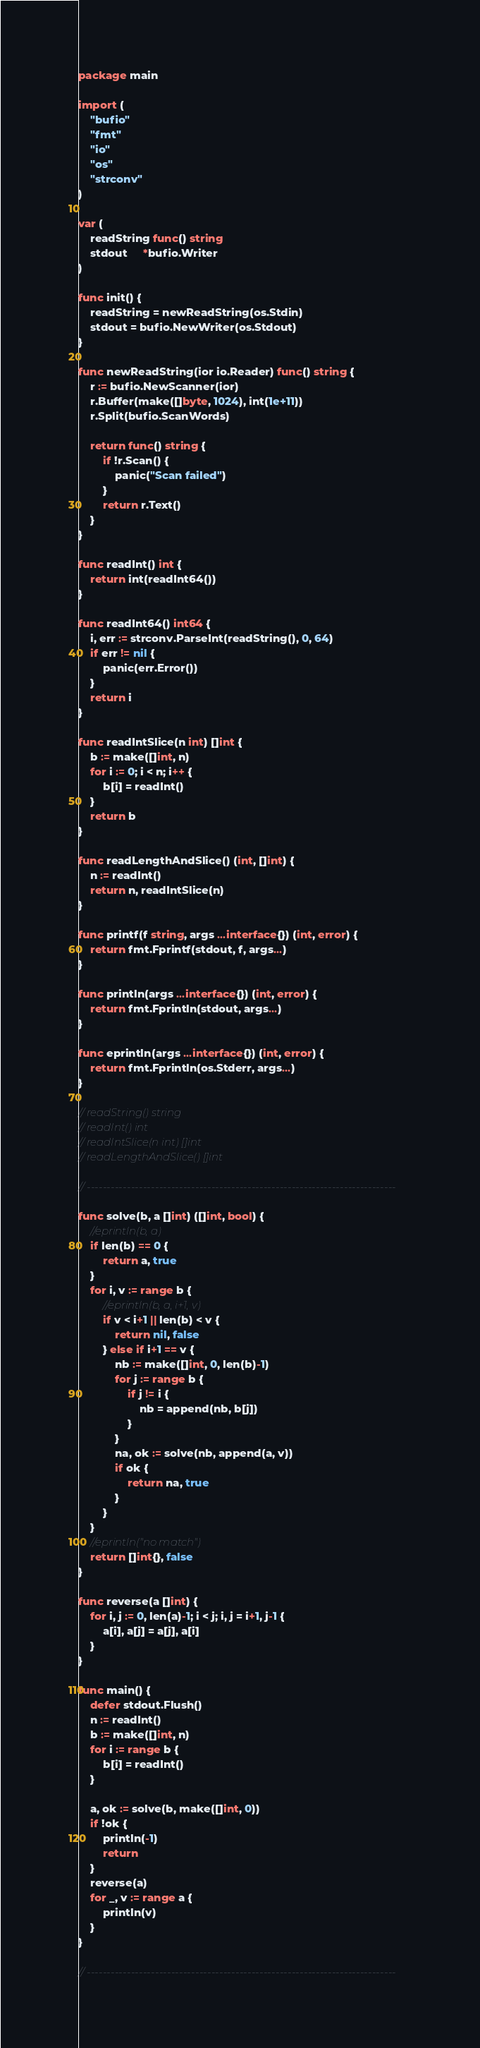<code> <loc_0><loc_0><loc_500><loc_500><_Go_>package main

import (
	"bufio"
	"fmt"
	"io"
	"os"
	"strconv"
)

var (
	readString func() string
	stdout     *bufio.Writer
)

func init() {
	readString = newReadString(os.Stdin)
	stdout = bufio.NewWriter(os.Stdout)
}

func newReadString(ior io.Reader) func() string {
	r := bufio.NewScanner(ior)
	r.Buffer(make([]byte, 1024), int(1e+11))
	r.Split(bufio.ScanWords)

	return func() string {
		if !r.Scan() {
			panic("Scan failed")
		}
		return r.Text()
	}
}

func readInt() int {
	return int(readInt64())
}

func readInt64() int64 {
	i, err := strconv.ParseInt(readString(), 0, 64)
	if err != nil {
		panic(err.Error())
	}
	return i
}

func readIntSlice(n int) []int {
	b := make([]int, n)
	for i := 0; i < n; i++ {
		b[i] = readInt()
	}
	return b
}

func readLengthAndSlice() (int, []int) {
	n := readInt()
	return n, readIntSlice(n)
}

func printf(f string, args ...interface{}) (int, error) {
	return fmt.Fprintf(stdout, f, args...)
}

func println(args ...interface{}) (int, error) {
	return fmt.Fprintln(stdout, args...)
}

func eprintln(args ...interface{}) (int, error) {
	return fmt.Fprintln(os.Stderr, args...)
}

// readString() string
// readInt() int
// readIntSlice(n int) []int
// readLengthAndSlice() []int

// -----------------------------------------------------------------------------

func solve(b, a []int) ([]int, bool) {
	//eprintln(b, a)
	if len(b) == 0 {
		return a, true
	}
	for i, v := range b {
		//eprintln(b, a, i+1, v)
		if v < i+1 || len(b) < v {
			return nil, false
		} else if i+1 == v {
			nb := make([]int, 0, len(b)-1)
			for j := range b {
				if j != i {
					nb = append(nb, b[j])
				}
			}
			na, ok := solve(nb, append(a, v))
			if ok {
				return na, true
			}
		}
	}
	//eprintln("no match")
	return []int{}, false
}

func reverse(a []int) {
	for i, j := 0, len(a)-1; i < j; i, j = i+1, j-1 {
		a[i], a[j] = a[j], a[i]
	}
}

func main() {
	defer stdout.Flush()
	n := readInt()
	b := make([]int, n)
	for i := range b {
		b[i] = readInt()
	}

	a, ok := solve(b, make([]int, 0))
	if !ok {
		println(-1)
		return
	}
	reverse(a)
	for _, v := range a {
		println(v)
	}
}

// -----------------------------------------------------------------------------
</code> 